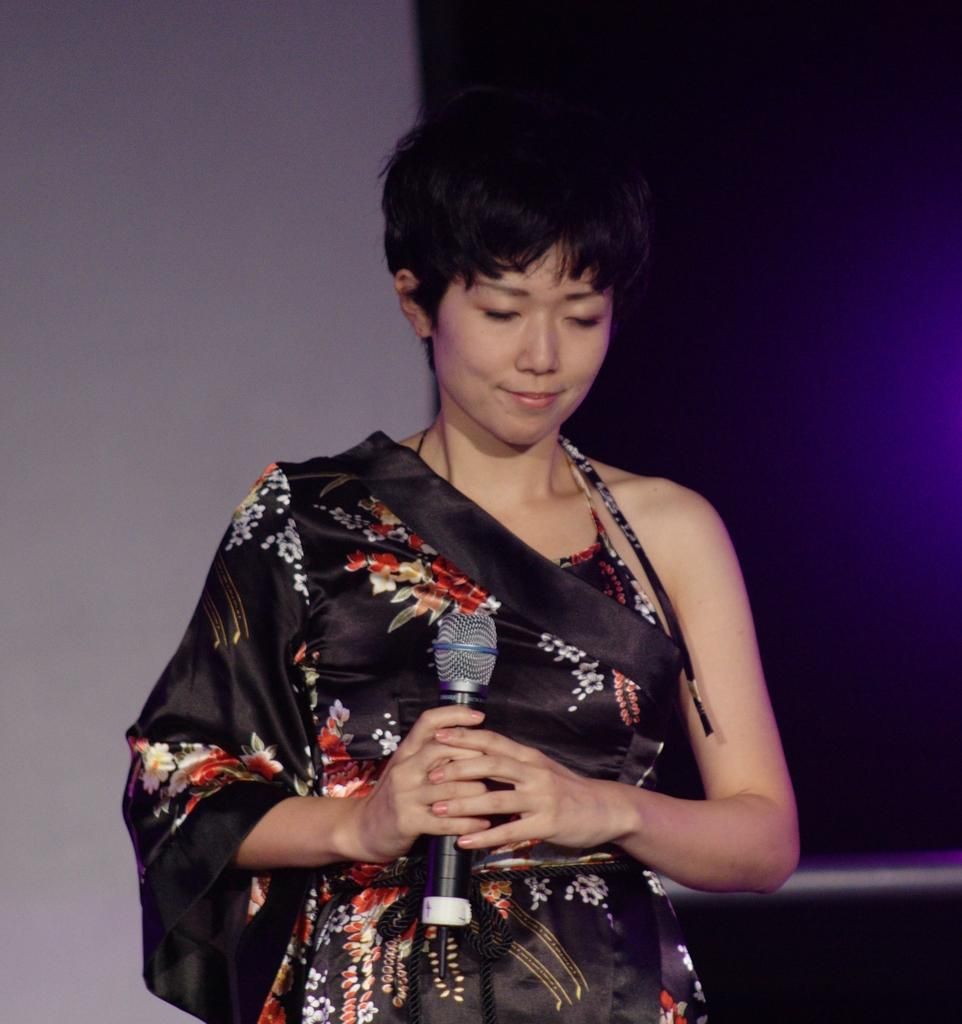Who is the main subject in the image? There is a woman in the image. What is the woman doing in the image? The woman is standing and holding a mic. What is the woman's facial expression in the image? The woman is smiling and has her eyes closed. What can be seen in the background of the image? There is a wall in the background of the image. What type of appliance is visible in the image? There is no appliance present in the image. How much does the woman weigh in the image? The weight of the woman cannot be determined from the image. 